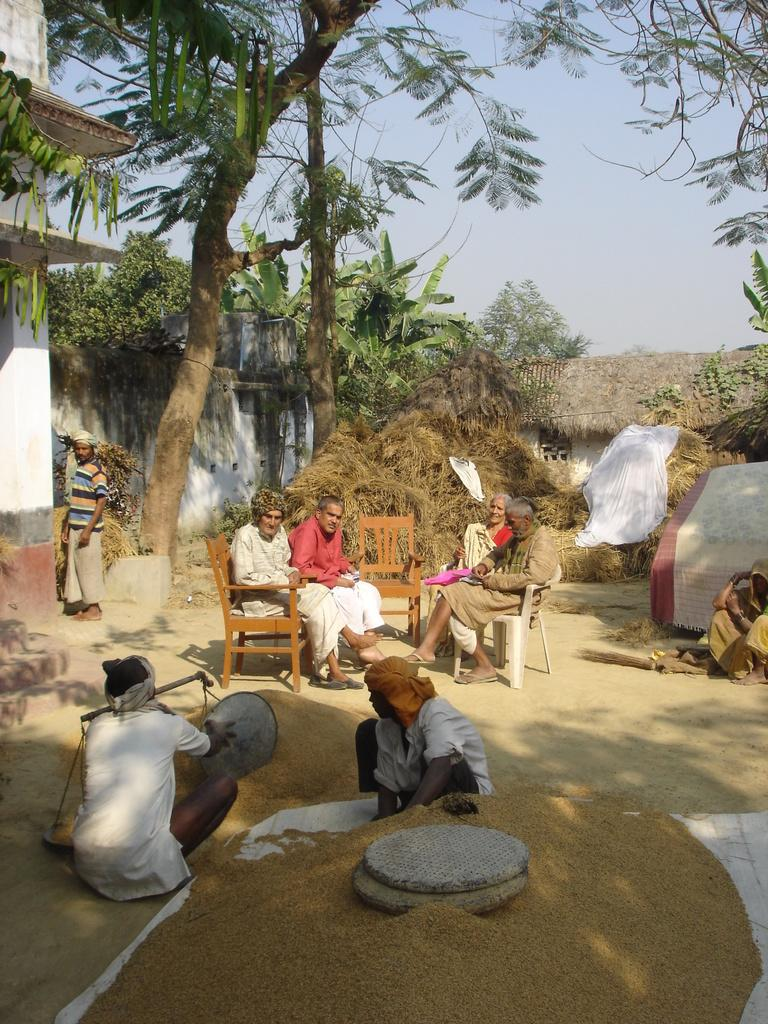How many people are in the image? There is a group of people in the image, but the exact number is not specified. What are the people doing in the image? The people are on the ground, but their specific activity is not mentioned. What can be seen in the background of the image? There are trees and the sky visible in the background of the image. What is the weight of the jelly in the image? There is no jelly present in the image, so its weight cannot be determined. 